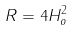<formula> <loc_0><loc_0><loc_500><loc_500>R = 4 H _ { o } ^ { 2 }</formula> 